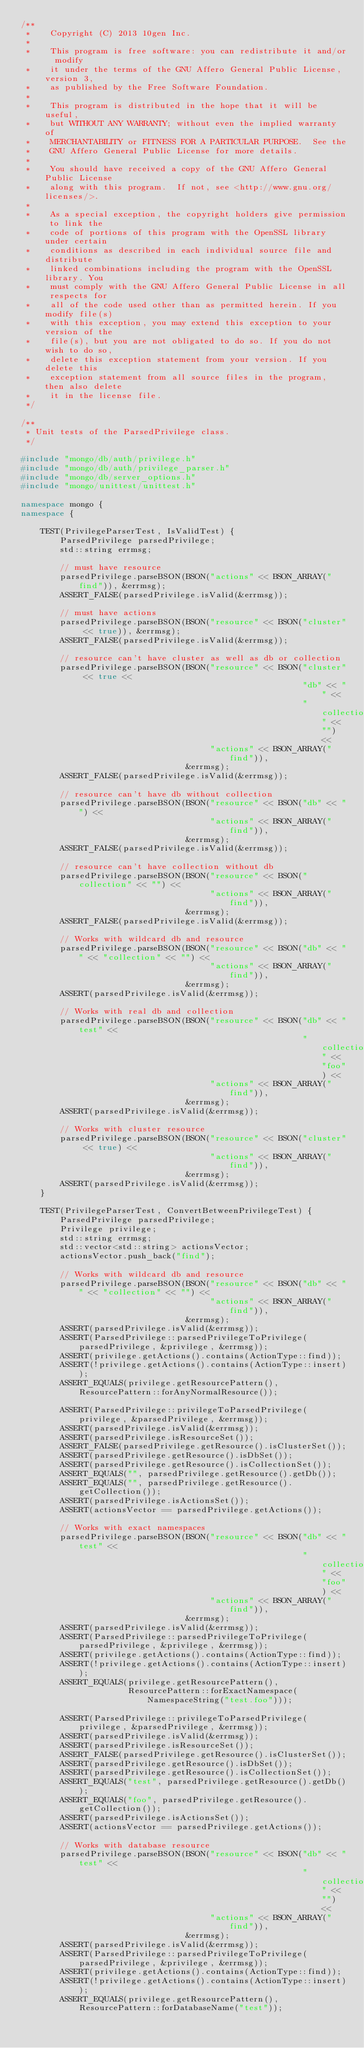<code> <loc_0><loc_0><loc_500><loc_500><_C++_>/**
 *    Copyright (C) 2013 10gen Inc.
 *
 *    This program is free software: you can redistribute it and/or  modify
 *    it under the terms of the GNU Affero General Public License, version 3,
 *    as published by the Free Software Foundation.
 *
 *    This program is distributed in the hope that it will be useful,
 *    but WITHOUT ANY WARRANTY; without even the implied warranty of
 *    MERCHANTABILITY or FITNESS FOR A PARTICULAR PURPOSE.  See the
 *    GNU Affero General Public License for more details.
 *
 *    You should have received a copy of the GNU Affero General Public License
 *    along with this program.  If not, see <http://www.gnu.org/licenses/>.
 *
 *    As a special exception, the copyright holders give permission to link the
 *    code of portions of this program with the OpenSSL library under certain
 *    conditions as described in each individual source file and distribute
 *    linked combinations including the program with the OpenSSL library. You
 *    must comply with the GNU Affero General Public License in all respects for
 *    all of the code used other than as permitted herein. If you modify file(s)
 *    with this exception, you may extend this exception to your version of the
 *    file(s), but you are not obligated to do so. If you do not wish to do so,
 *    delete this exception statement from your version. If you delete this
 *    exception statement from all source files in the program, then also delete
 *    it in the license file.
 */

/**
 * Unit tests of the ParsedPrivilege class.
 */

#include "mongo/db/auth/privilege.h"
#include "mongo/db/auth/privilege_parser.h"
#include "mongo/db/server_options.h"
#include "mongo/unittest/unittest.h"

namespace mongo {
namespace {

    TEST(PrivilegeParserTest, IsValidTest) {
        ParsedPrivilege parsedPrivilege;
        std::string errmsg;

        // must have resource
        parsedPrivilege.parseBSON(BSON("actions" << BSON_ARRAY("find")), &errmsg);
        ASSERT_FALSE(parsedPrivilege.isValid(&errmsg));

        // must have actions
        parsedPrivilege.parseBSON(BSON("resource" << BSON("cluster" << true)), &errmsg);
        ASSERT_FALSE(parsedPrivilege.isValid(&errmsg));

        // resource can't have cluster as well as db or collection
        parsedPrivilege.parseBSON(BSON("resource" << BSON("cluster" << true <<
                                                          "db" << "" <<
                                                          "collection" << "") <<
                                       "actions" << BSON_ARRAY("find")),
                                  &errmsg);
        ASSERT_FALSE(parsedPrivilege.isValid(&errmsg));

        // resource can't have db without collection
        parsedPrivilege.parseBSON(BSON("resource" << BSON("db" << "") <<
                                       "actions" << BSON_ARRAY("find")),
                                  &errmsg);
        ASSERT_FALSE(parsedPrivilege.isValid(&errmsg));

        // resource can't have collection without db
        parsedPrivilege.parseBSON(BSON("resource" << BSON("collection" << "") <<
                                       "actions" << BSON_ARRAY("find")),
                                  &errmsg);
        ASSERT_FALSE(parsedPrivilege.isValid(&errmsg));

        // Works with wildcard db and resource
        parsedPrivilege.parseBSON(BSON("resource" << BSON("db" << "" << "collection" << "") <<
                                       "actions" << BSON_ARRAY("find")),
                                  &errmsg);
        ASSERT(parsedPrivilege.isValid(&errmsg));

        // Works with real db and collection
        parsedPrivilege.parseBSON(BSON("resource" << BSON("db" << "test" <<
                                                          "collection" << "foo") <<
                                       "actions" << BSON_ARRAY("find")),
                                  &errmsg);
        ASSERT(parsedPrivilege.isValid(&errmsg));

        // Works with cluster resource
        parsedPrivilege.parseBSON(BSON("resource" << BSON("cluster" << true) <<
                                       "actions" << BSON_ARRAY("find")),
                                  &errmsg);
        ASSERT(parsedPrivilege.isValid(&errmsg));
    }

    TEST(PrivilegeParserTest, ConvertBetweenPrivilegeTest) {
        ParsedPrivilege parsedPrivilege;
        Privilege privilege;
        std::string errmsg;
        std::vector<std::string> actionsVector;
        actionsVector.push_back("find");

        // Works with wildcard db and resource
        parsedPrivilege.parseBSON(BSON("resource" << BSON("db" << "" << "collection" << "") <<
                                       "actions" << BSON_ARRAY("find")),
                                  &errmsg);
        ASSERT(parsedPrivilege.isValid(&errmsg));
        ASSERT(ParsedPrivilege::parsedPrivilegeToPrivilege(parsedPrivilege, &privilege, &errmsg));
        ASSERT(privilege.getActions().contains(ActionType::find));
        ASSERT(!privilege.getActions().contains(ActionType::insert));
        ASSERT_EQUALS(privilege.getResourcePattern(), ResourcePattern::forAnyNormalResource());

        ASSERT(ParsedPrivilege::privilegeToParsedPrivilege(privilege, &parsedPrivilege, &errmsg));
        ASSERT(parsedPrivilege.isValid(&errmsg));
        ASSERT(parsedPrivilege.isResourceSet());
        ASSERT_FALSE(parsedPrivilege.getResource().isClusterSet());
        ASSERT(parsedPrivilege.getResource().isDbSet());
        ASSERT(parsedPrivilege.getResource().isCollectionSet());
        ASSERT_EQUALS("", parsedPrivilege.getResource().getDb());
        ASSERT_EQUALS("", parsedPrivilege.getResource().getCollection());
        ASSERT(parsedPrivilege.isActionsSet());
        ASSERT(actionsVector == parsedPrivilege.getActions());

        // Works with exact namespaces
        parsedPrivilege.parseBSON(BSON("resource" << BSON("db" << "test" <<
                                                          "collection" << "foo") <<
                                       "actions" << BSON_ARRAY("find")),
                                  &errmsg);
        ASSERT(parsedPrivilege.isValid(&errmsg));
        ASSERT(ParsedPrivilege::parsedPrivilegeToPrivilege(parsedPrivilege, &privilege, &errmsg));
        ASSERT(privilege.getActions().contains(ActionType::find));
        ASSERT(!privilege.getActions().contains(ActionType::insert));
        ASSERT_EQUALS(privilege.getResourcePattern(),
                      ResourcePattern::forExactNamespace(NamespaceString("test.foo")));

        ASSERT(ParsedPrivilege::privilegeToParsedPrivilege(privilege, &parsedPrivilege, &errmsg));
        ASSERT(parsedPrivilege.isValid(&errmsg));
        ASSERT(parsedPrivilege.isResourceSet());
        ASSERT_FALSE(parsedPrivilege.getResource().isClusterSet());
        ASSERT(parsedPrivilege.getResource().isDbSet());
        ASSERT(parsedPrivilege.getResource().isCollectionSet());
        ASSERT_EQUALS("test", parsedPrivilege.getResource().getDb());
        ASSERT_EQUALS("foo", parsedPrivilege.getResource().getCollection());
        ASSERT(parsedPrivilege.isActionsSet());
        ASSERT(actionsVector == parsedPrivilege.getActions());

        // Works with database resource
        parsedPrivilege.parseBSON(BSON("resource" << BSON("db" << "test" <<
                                                          "collection" << "") <<
                                       "actions" << BSON_ARRAY("find")),
                                  &errmsg);
        ASSERT(parsedPrivilege.isValid(&errmsg));
        ASSERT(ParsedPrivilege::parsedPrivilegeToPrivilege(parsedPrivilege, &privilege, &errmsg));
        ASSERT(privilege.getActions().contains(ActionType::find));
        ASSERT(!privilege.getActions().contains(ActionType::insert));
        ASSERT_EQUALS(privilege.getResourcePattern(), ResourcePattern::forDatabaseName("test"));
</code> 